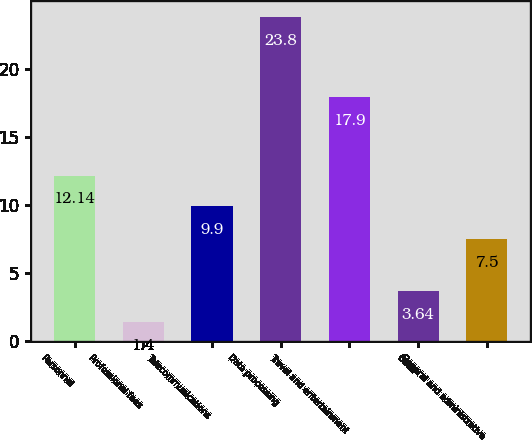Convert chart to OTSL. <chart><loc_0><loc_0><loc_500><loc_500><bar_chart><fcel>Personnel<fcel>Professional fees<fcel>Telecommunications<fcel>Data processing<fcel>Travel and entertainment<fcel>Other<fcel>General and administrative<nl><fcel>12.14<fcel>1.4<fcel>9.9<fcel>23.8<fcel>17.9<fcel>3.64<fcel>7.5<nl></chart> 